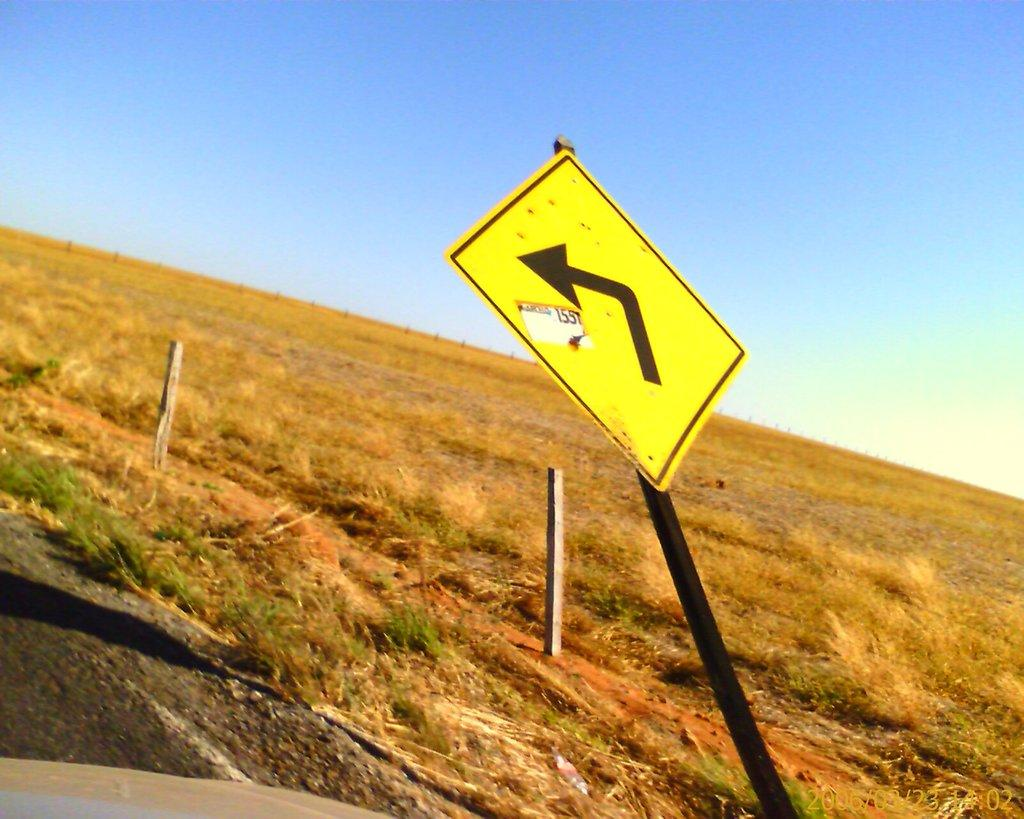What is located in the center of the image? There are poles in the center of the image. What is attached to the poles? There is a sign board on the poles. What can be seen in the background of the image? The sky, a fence, and grass are visible in the background of the image. What type of veil can be seen covering the bear in the image? There is no veil or bear present in the image. How much powder is needed to cover the entire area in the image? There is no mention of powder or any area that needs to be covered in the image. 